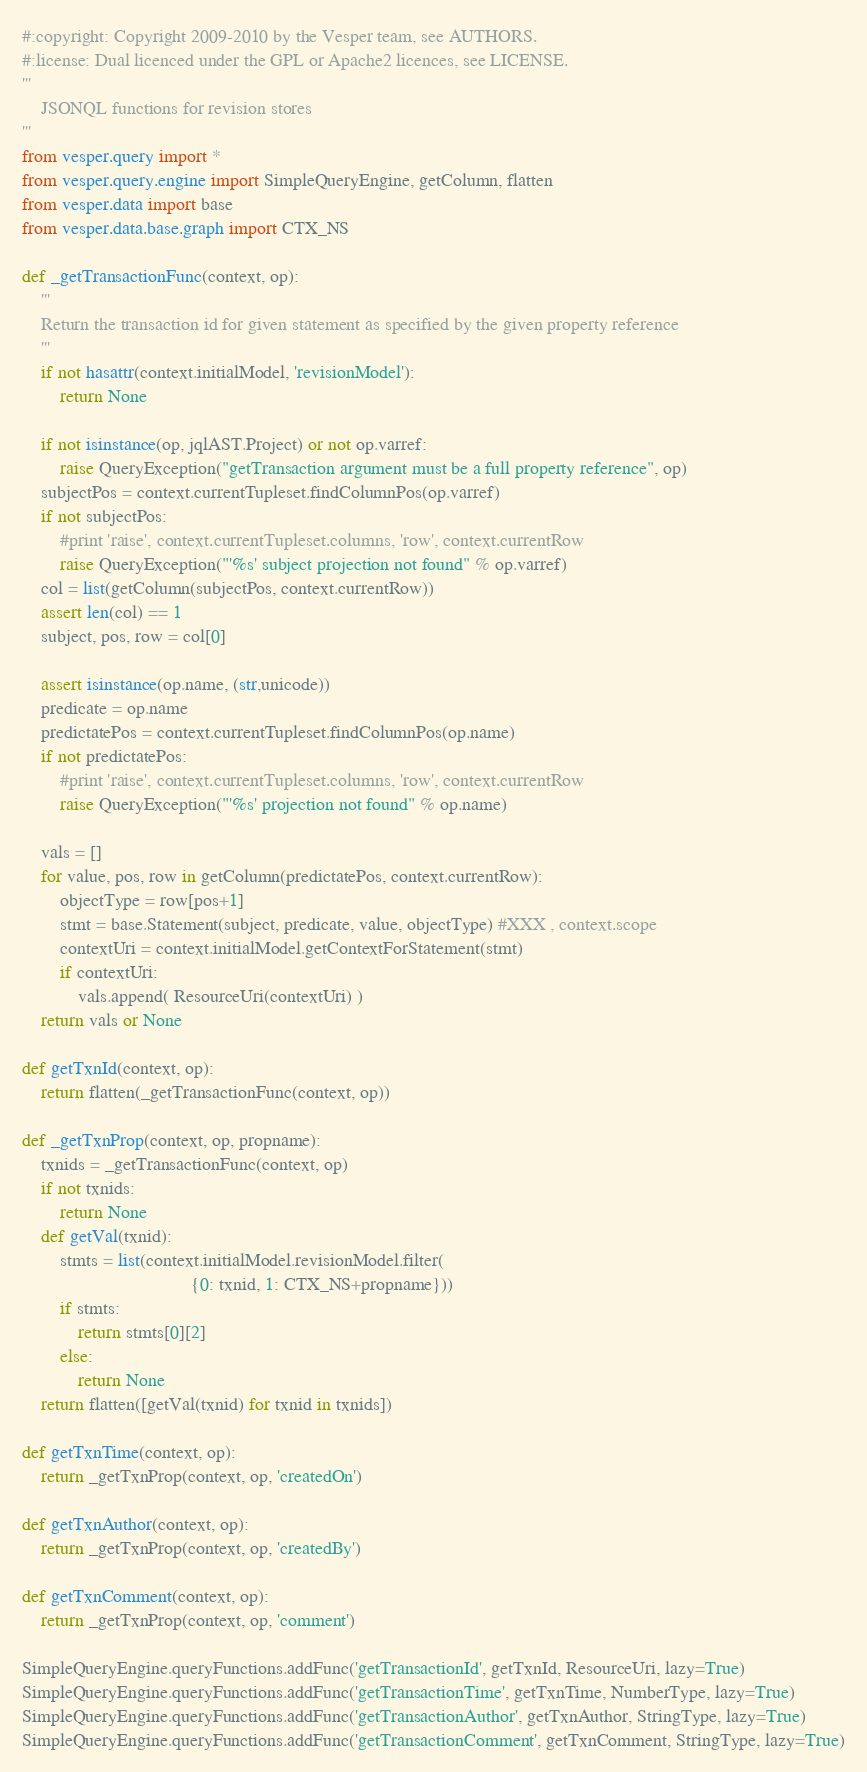<code> <loc_0><loc_0><loc_500><loc_500><_Python_>#:copyright: Copyright 2009-2010 by the Vesper team, see AUTHORS.
#:license: Dual licenced under the GPL or Apache2 licences, see LICENSE.
'''
    JSONQL functions for revision stores
'''
from vesper.query import *
from vesper.query.engine import SimpleQueryEngine, getColumn, flatten
from vesper.data import base
from vesper.data.base.graph import CTX_NS

def _getTransactionFunc(context, op):
    '''
    Return the transaction id for given statement as specified by the given property reference
    '''
    if not hasattr(context.initialModel, 'revisionModel'):
        return None
    
    if not isinstance(op, jqlAST.Project) or not op.varref:
        raise QueryException("getTransaction argument must be a full property reference", op)
    subjectPos = context.currentTupleset.findColumnPos(op.varref)
    if not subjectPos:        
        #print 'raise', context.currentTupleset.columns, 'row', context.currentRow
        raise QueryException("'%s' subject projection not found" % op.varref)
    col = list(getColumn(subjectPos, context.currentRow))
    assert len(col) == 1
    subject, pos, row = col[0]

    assert isinstance(op.name, (str,unicode))
    predicate = op.name
    predictatePos = context.currentTupleset.findColumnPos(op.name)
    if not predictatePos:
        #print 'raise', context.currentTupleset.columns, 'row', context.currentRow
        raise QueryException("'%s' projection not found" % op.name)
    
    vals = []
    for value, pos, row in getColumn(predictatePos, context.currentRow):
        objectType = row[pos+1]    
        stmt = base.Statement(subject, predicate, value, objectType) #XXX , context.scope
        contextUri = context.initialModel.getContextForStatement(stmt)
        if contextUri:            
            vals.append( ResourceUri(contextUri) )
    return vals or None

def getTxnId(context, op):
    return flatten(_getTransactionFunc(context, op))

def _getTxnProp(context, op, propname):
    txnids = _getTransactionFunc(context, op)
    if not txnids:
        return None
    def getVal(txnid):
        stmts = list(context.initialModel.revisionModel.filter(
                                    {0: txnid, 1: CTX_NS+propname}))
        if stmts:
            return stmts[0][2]
        else:
            return None
    return flatten([getVal(txnid) for txnid in txnids])

def getTxnTime(context, op):
    return _getTxnProp(context, op, 'createdOn')

def getTxnAuthor(context, op):
    return _getTxnProp(context, op, 'createdBy')

def getTxnComment(context, op):
    return _getTxnProp(context, op, 'comment')

SimpleQueryEngine.queryFunctions.addFunc('getTransactionId', getTxnId, ResourceUri, lazy=True)
SimpleQueryEngine.queryFunctions.addFunc('getTransactionTime', getTxnTime, NumberType, lazy=True)
SimpleQueryEngine.queryFunctions.addFunc('getTransactionAuthor', getTxnAuthor, StringType, lazy=True)
SimpleQueryEngine.queryFunctions.addFunc('getTransactionComment', getTxnComment, StringType, lazy=True)
</code> 